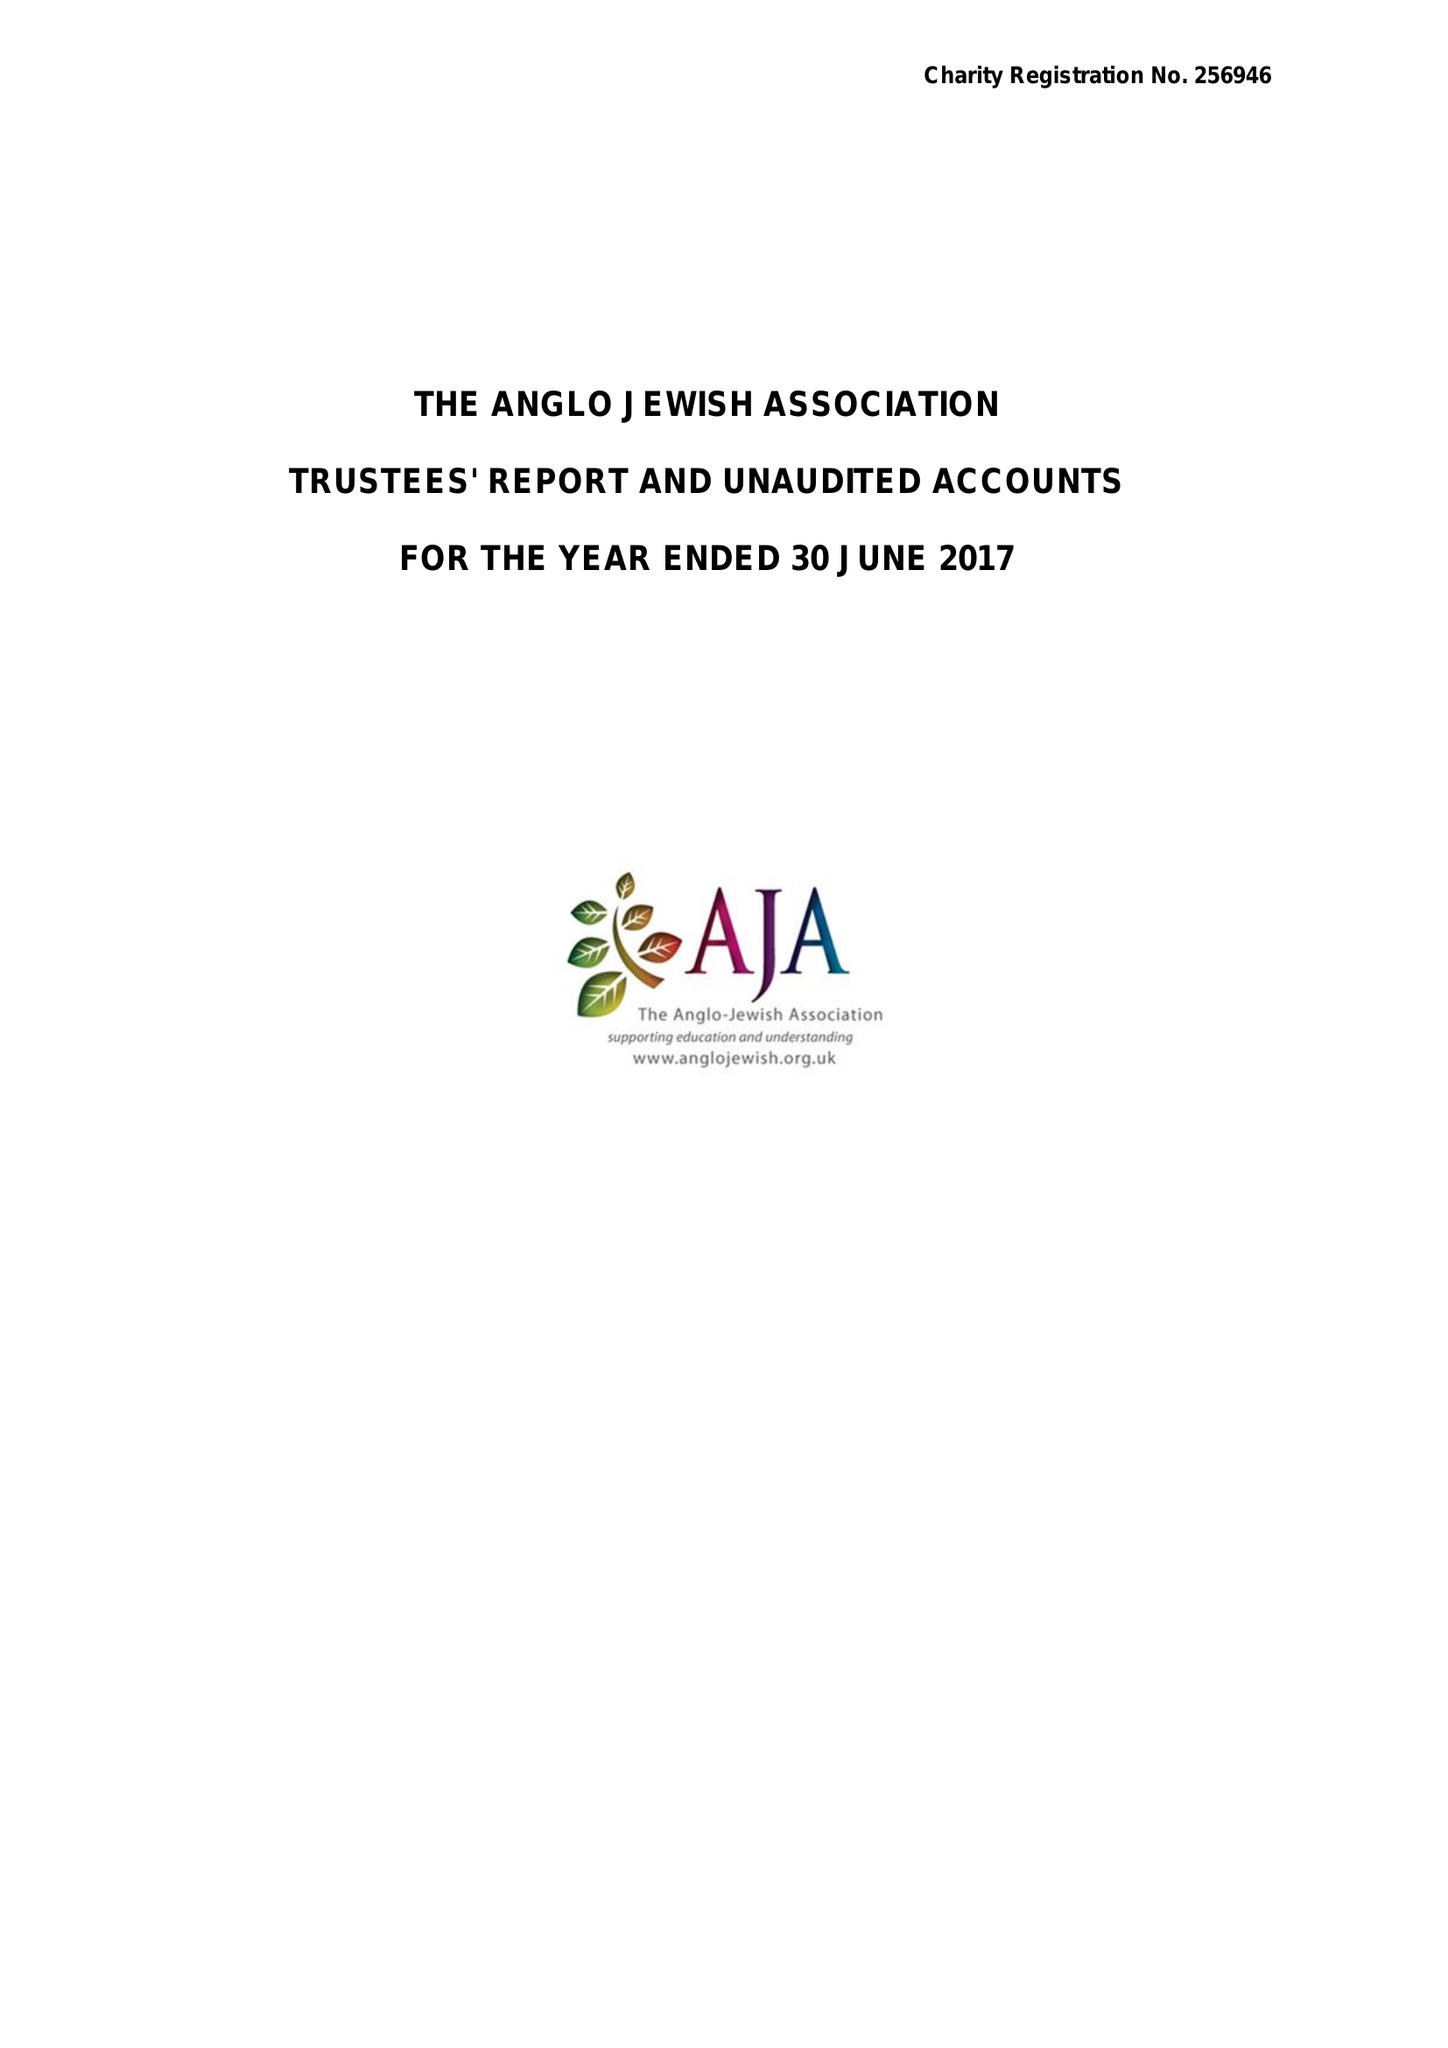What is the value for the income_annually_in_british_pounds?
Answer the question using a single word or phrase. 31970.00 